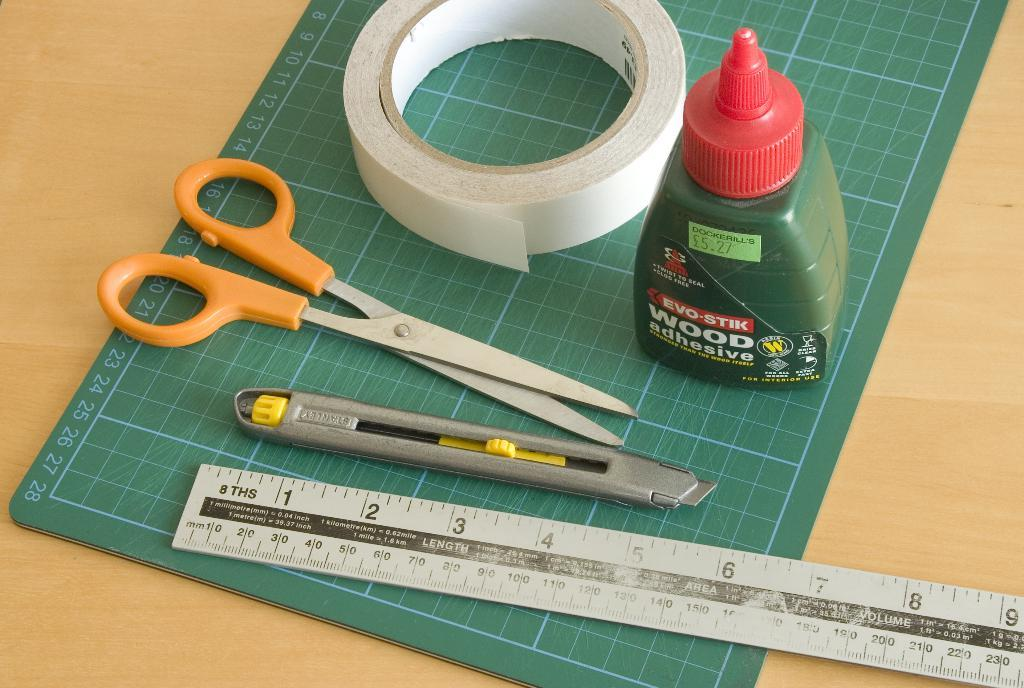<image>
Share a concise interpretation of the image provided. A silicon mat and cutting tools and a bottle of wood adhesive. 